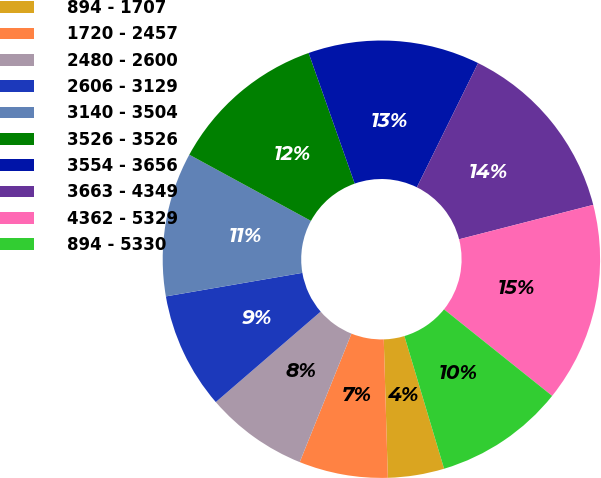Convert chart to OTSL. <chart><loc_0><loc_0><loc_500><loc_500><pie_chart><fcel>894 - 1707<fcel>1720 - 2457<fcel>2480 - 2600<fcel>2606 - 3129<fcel>3140 - 3504<fcel>3526 - 3526<fcel>3554 - 3656<fcel>3663 - 4349<fcel>4362 - 5329<fcel>894 - 5330<nl><fcel>4.16%<fcel>6.56%<fcel>7.58%<fcel>8.61%<fcel>10.65%<fcel>11.67%<fcel>12.69%<fcel>13.71%<fcel>14.74%<fcel>9.63%<nl></chart> 